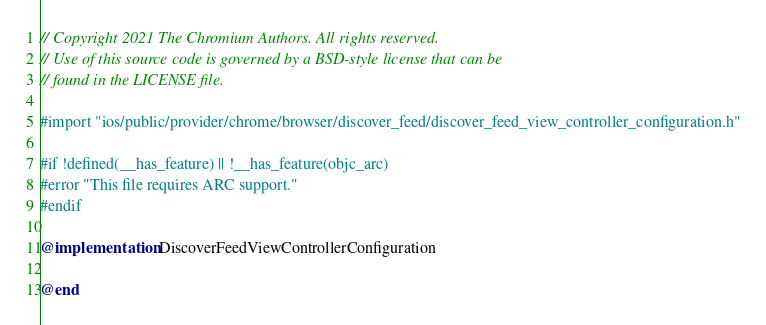<code> <loc_0><loc_0><loc_500><loc_500><_ObjectiveC_>// Copyright 2021 The Chromium Authors. All rights reserved.
// Use of this source code is governed by a BSD-style license that can be
// found in the LICENSE file.

#import "ios/public/provider/chrome/browser/discover_feed/discover_feed_view_controller_configuration.h"

#if !defined(__has_feature) || !__has_feature(objc_arc)
#error "This file requires ARC support."
#endif

@implementation DiscoverFeedViewControllerConfiguration

@end
</code> 